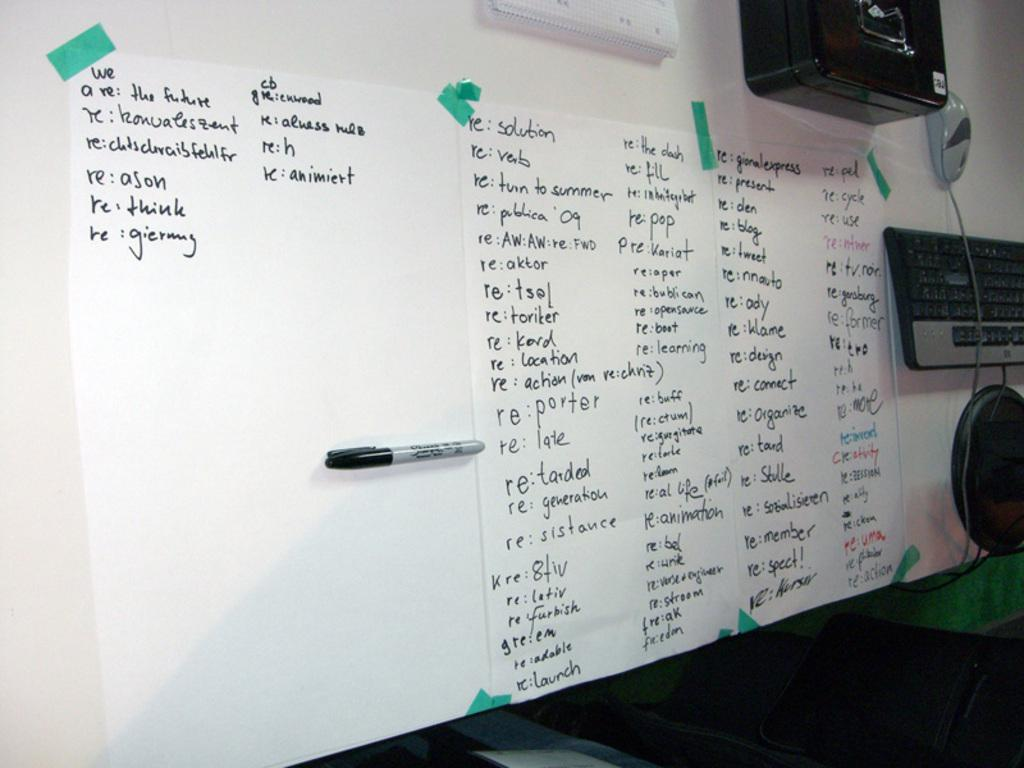<image>
Share a concise interpretation of the image provided. An white board with paper taped to it holding a large piece of paper with the first sentenec saying, "We are the future." 